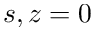Convert formula to latex. <formula><loc_0><loc_0><loc_500><loc_500>s , z = 0</formula> 